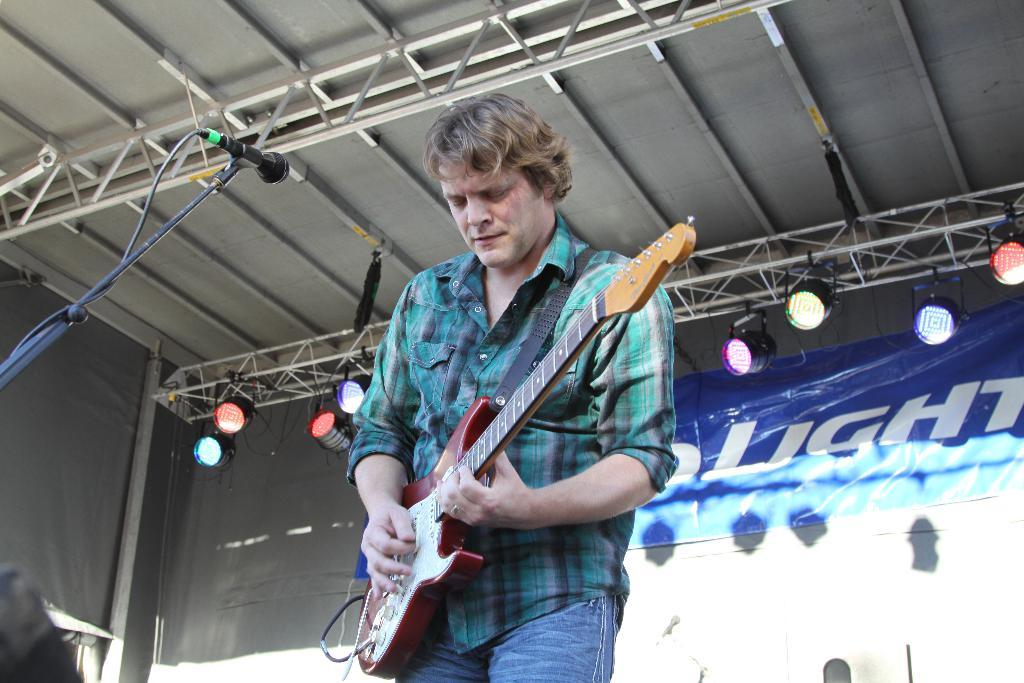What is the man in the image doing? The man is playing a guitar in the image. What object is the man standing near? The man is standing in front of a microphone. Can you describe the setting of the image? The setting appears to be a shed. What additional feature can be seen in the image? There are focusing lights on top. Is there any text or signage visible in the image? A banner is attached to a wall. How many rabbits can be seen in the wilderness in the image? There are no rabbits or wilderness present in the image. 